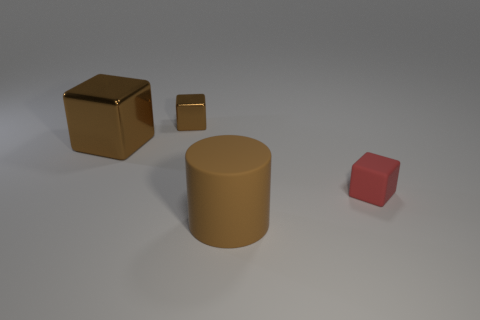Add 4 large rubber balls. How many objects exist? 8 Subtract all cubes. How many objects are left? 1 Subtract 0 blue spheres. How many objects are left? 4 Subtract all brown matte cylinders. Subtract all gray things. How many objects are left? 3 Add 1 matte cylinders. How many matte cylinders are left? 2 Add 4 cyan blocks. How many cyan blocks exist? 4 